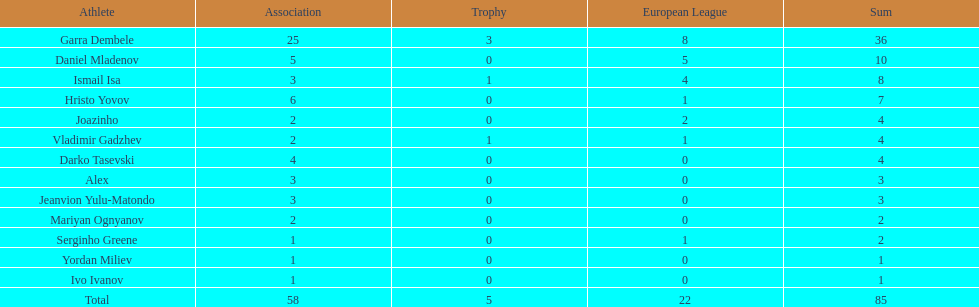Could you help me parse every detail presented in this table? {'header': ['Athlete', 'Association', 'Trophy', 'European League', 'Sum'], 'rows': [['Garra Dembele', '25', '3', '8', '36'], ['Daniel Mladenov', '5', '0', '5', '10'], ['Ismail Isa', '3', '1', '4', '8'], ['Hristo Yovov', '6', '0', '1', '7'], ['Joazinho', '2', '0', '2', '4'], ['Vladimir Gadzhev', '2', '1', '1', '4'], ['Darko Tasevski', '4', '0', '0', '4'], ['Alex', '3', '0', '0', '3'], ['Jeanvion Yulu-Matondo', '3', '0', '0', '3'], ['Mariyan Ognyanov', '2', '0', '0', '2'], ['Serginho Greene', '1', '0', '1', '2'], ['Yordan Miliev', '1', '0', '0', '1'], ['Ivo Ivanov', '1', '0', '0', '1'], ['Total', '58', '5', '22', '85']]} How many players did not score a goal in cup play? 10. 